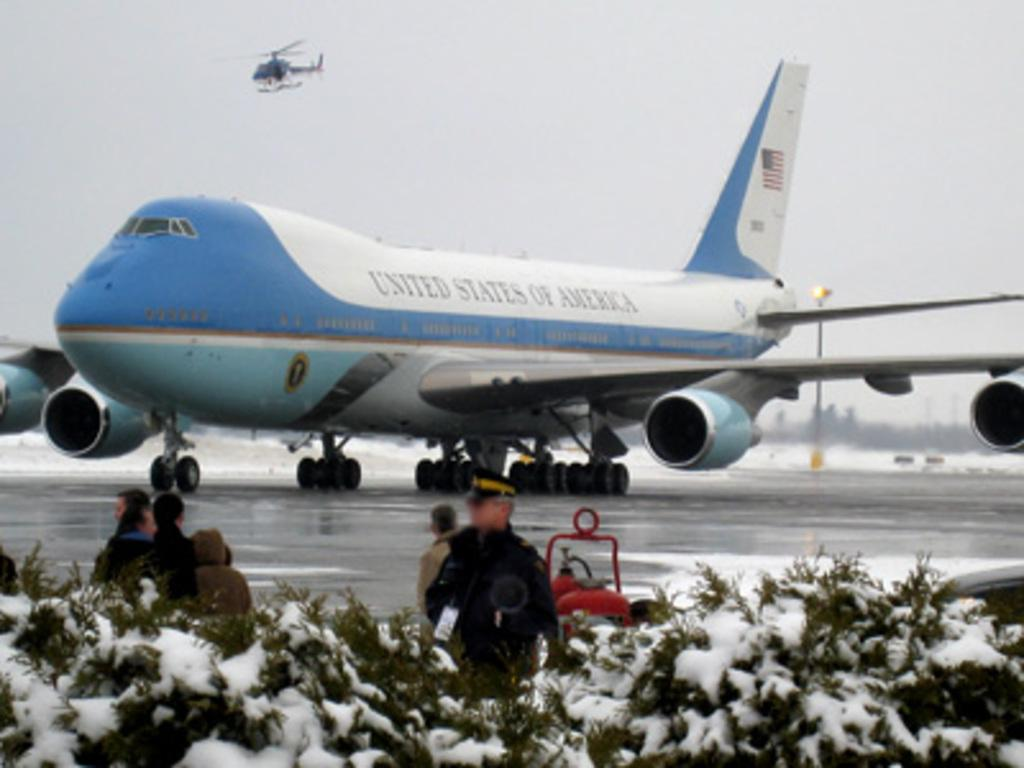<image>
Describe the image concisely. A United States of America plane is parked on the tarmac. 